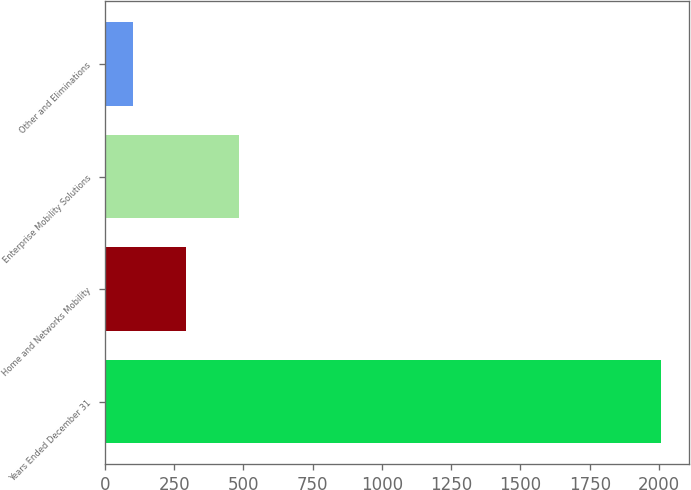<chart> <loc_0><loc_0><loc_500><loc_500><bar_chart><fcel>Years Ended December 31<fcel>Home and Networks Mobility<fcel>Enterprise Mobility Solutions<fcel>Other and Eliminations<nl><fcel>2008<fcel>293.5<fcel>484<fcel>103<nl></chart> 